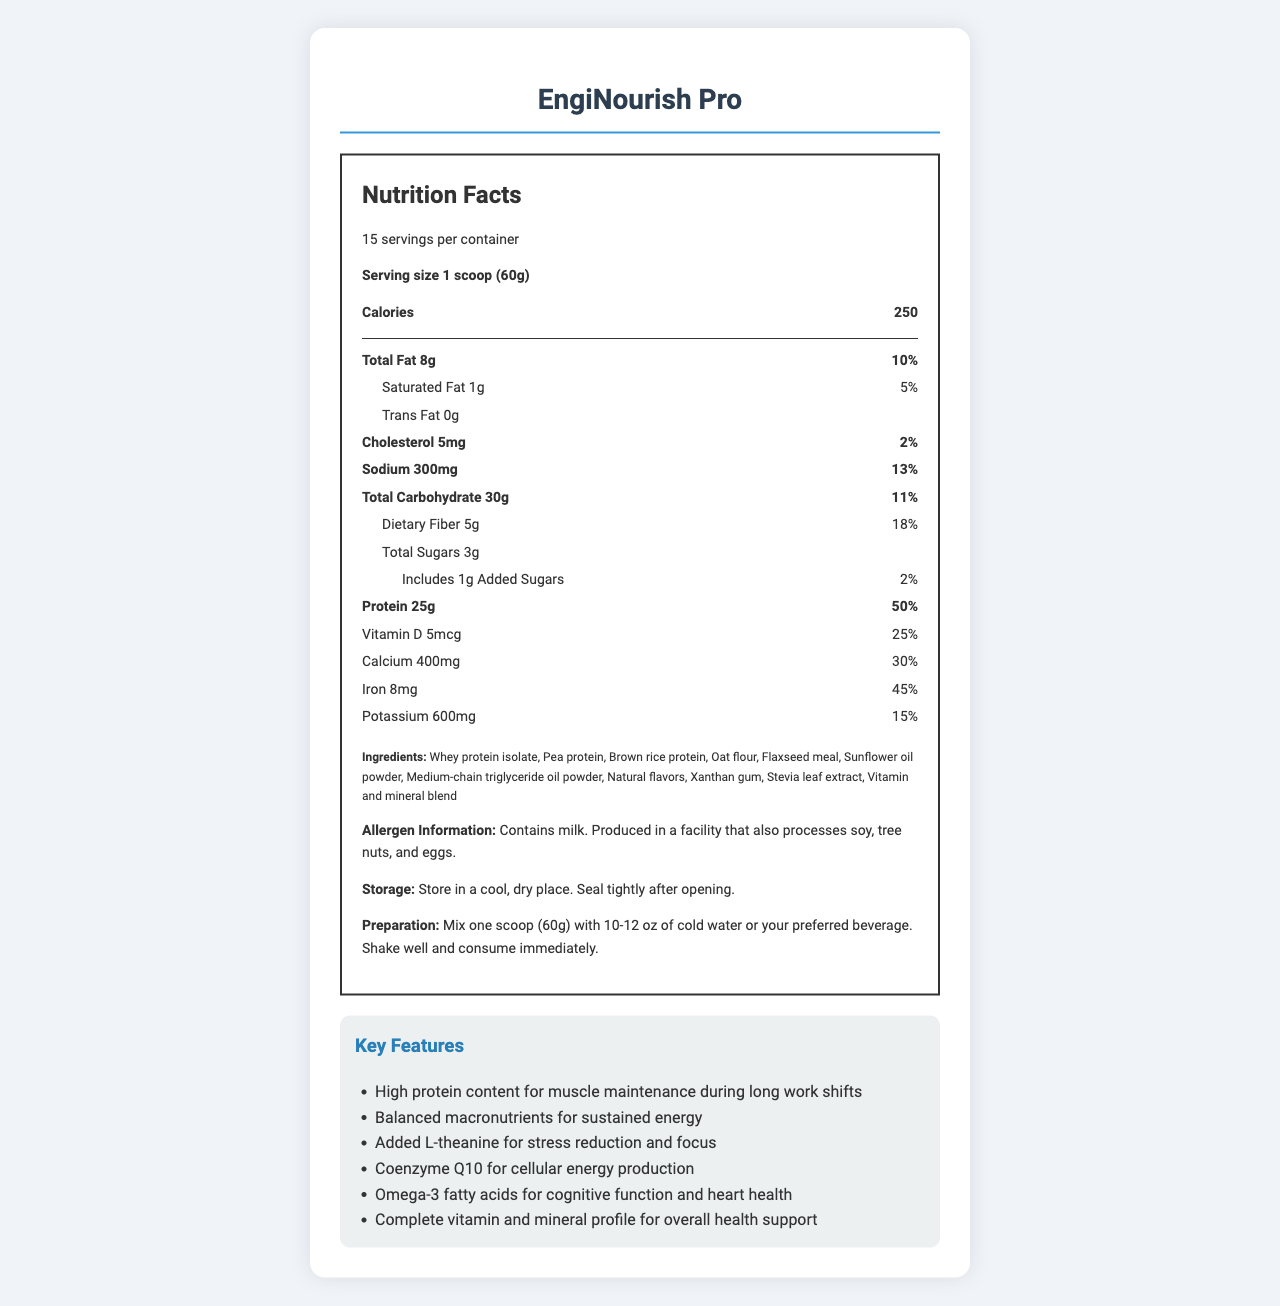What is the serving size for EngiNourish Pro? The serving size is listed as "1 scoop (60g)" in the document.
Answer: 1 scoop (60g) How many calories are in one serving of EngiNourish Pro? The calories per serving are shown as 250.
Answer: 250 What is the main source of protein in EngiNourish Pro? The first ingredient listed is "Whey protein isolate," indicating it is a primary protein source.
Answer: Whey protein isolate How much dietary fiber does one serving contain? The document lists dietary fiber as 5g per serving.
Answer: 5g What is the shelf life of EngiNourish Pro? The shelf life is mentioned as "18 months from date of manufacture when stored as directed."
Answer: 18 months Which vitamin has the highest daily value percentage? A. Vitamin D B. Vitamin C C. Thiamin D. Vitamin B12 Thiamin has a daily value percentage of 100%, the highest listed in the document.
Answer: C. Thiamin Which of these features is not listed as a key feature of EngiNourish Pro? A. Omega-3 fatty acids for cognitive function and heart health B. High fiber content for digestive health C. Coenzyme Q10 for cellular energy production D. Balanced macronutrients for sustained energy The document lists several key features, but "High fiber content for digestive health" is not mentioned.
Answer: B. High fiber content for digestive health Does EngiNourish Pro contain any added sugars? The document states that it contains 1g of added sugars (2% daily value).
Answer: Yes Can EngiNourish Pro be suitable for someone with a tree nut allergy? Although tree nuts are mentioned as a possible contaminant, without more information about the severity of the allergy, it is not possible to determine suitability.
Answer: Not enough information Summarize what the document is about. The document provides comprehensive information about EngiNourish Pro, from its nutritional content and ingredients to its intended users and key health benefits.
Answer: The document is a detailed nutrient analysis of EngiNourish Pro, a meal replacement shake tailored for professionals with irregular work schedules. It includes nutritional facts, ingredients, allergen information, storage and preparation instructions, key features, and the product's target audience. How many grams of total fat are in each serving of EngiNourish Pro? The total fat content per serving is listed as 8g.
Answer: 8g What is the percentage daily value of protein provided by one serving? The document shows that one serving provides 50% of the daily value for protein.
Answer: 50% What are the two special ingredients listed that provide additional health benefits? The key features section mentions L-theanine for stress reduction and focus, and coenzyme Q10 for cellular energy production.
Answer: L-theanine and coenzyme Q10 Is the product suitable for vegetarians? EngiNourish Pro contains whey protein isolate, which is derived from milk, making it unsuitable for vegetarians.
Answer: No 